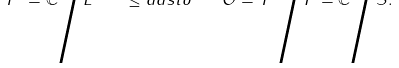<formula> <loc_0><loc_0><loc_500><loc_500>T ^ { 2 } = \mathbb { C } \Big { / } L \quad \leq a d s t o \quad \mathcal { O } = T ^ { 2 } \Big { / } P = \mathbb { C } \Big { / } S .</formula> 